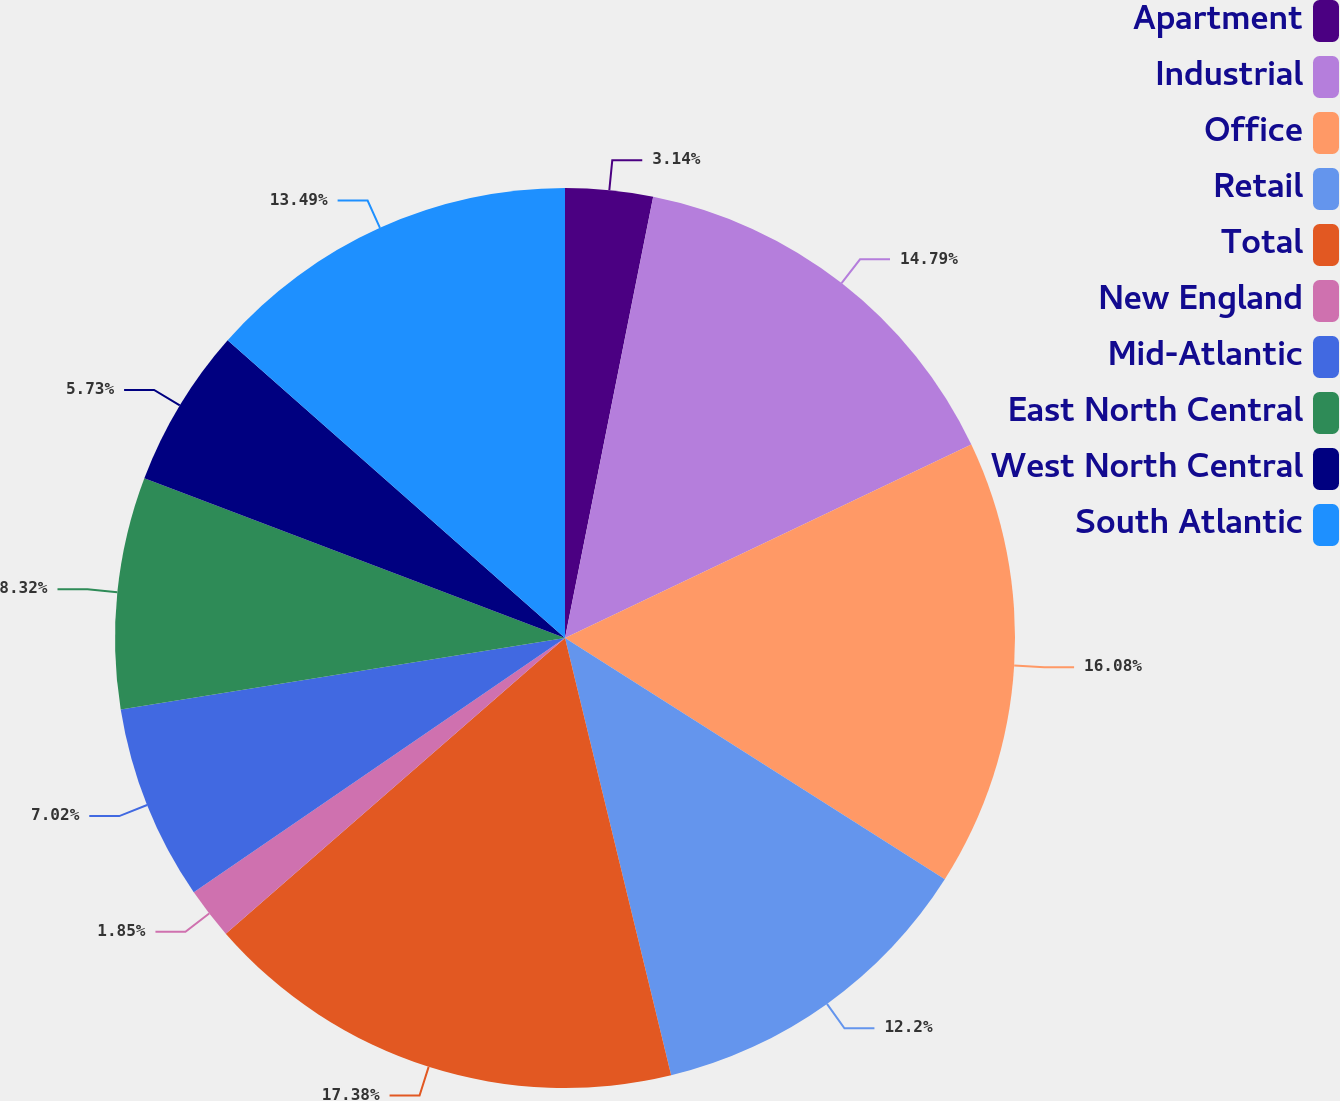<chart> <loc_0><loc_0><loc_500><loc_500><pie_chart><fcel>Apartment<fcel>Industrial<fcel>Office<fcel>Retail<fcel>Total<fcel>New England<fcel>Mid-Atlantic<fcel>East North Central<fcel>West North Central<fcel>South Atlantic<nl><fcel>3.14%<fcel>14.79%<fcel>16.08%<fcel>12.2%<fcel>17.38%<fcel>1.85%<fcel>7.02%<fcel>8.32%<fcel>5.73%<fcel>13.49%<nl></chart> 